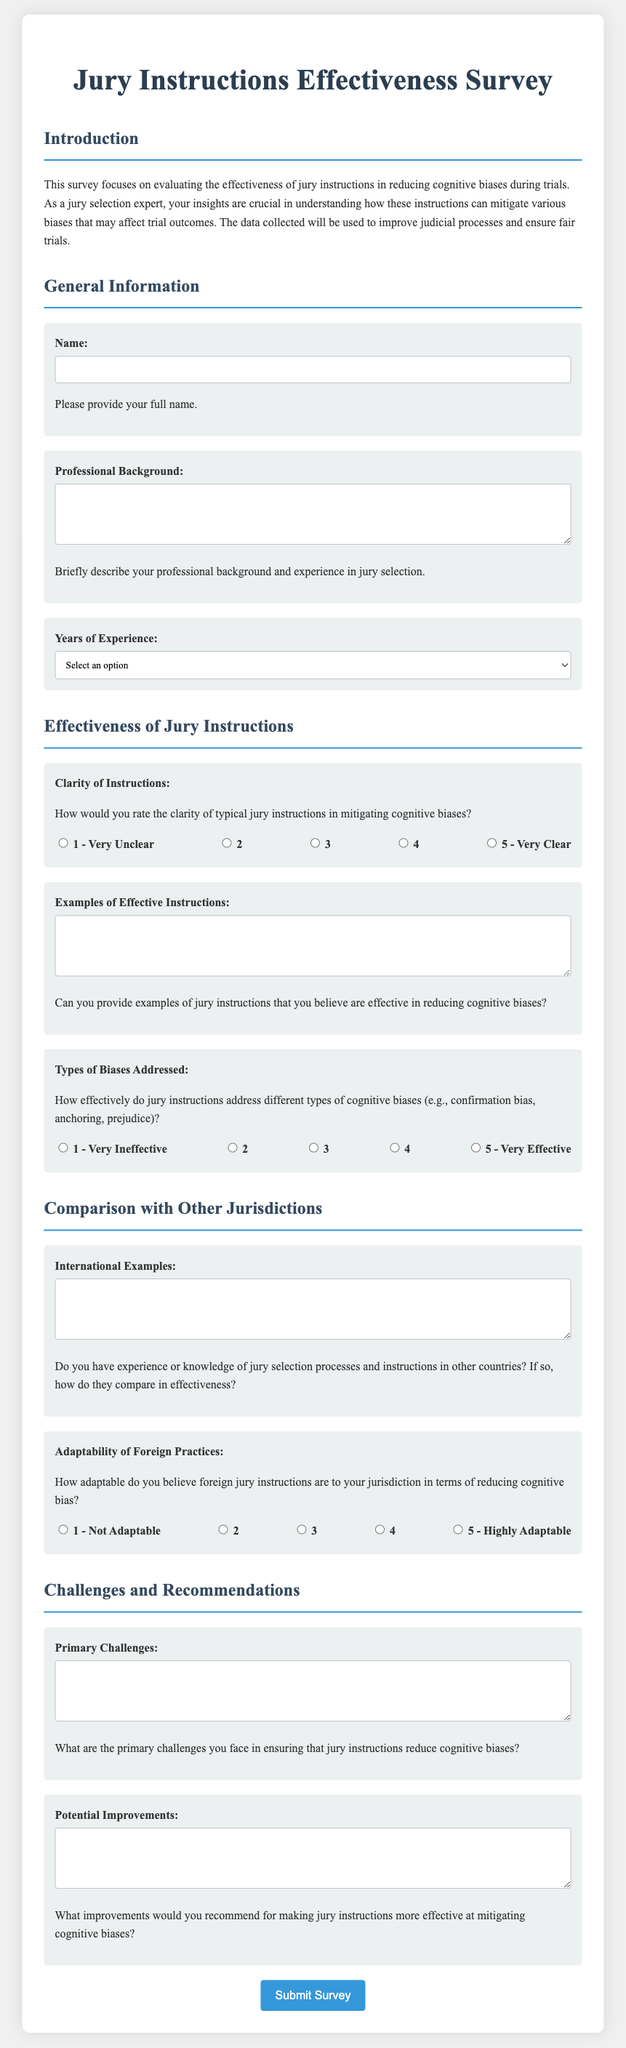What is the title of the survey? The title of the survey is stated at the top of the document.
Answer: Jury Instructions Effectiveness Survey How many sections are there in the survey? The survey has multiple distinct sections for organization, each addressing different themes.
Answer: 5 What is the required response for the "Name" question? The instructions indicate that the "Name" question must be filled out.
Answer: Full name What rating scale options are provided for the clarity of instructions? The document lists a range of one to five to rate clarity.
Answer: 1 to 5 What type of information is requested in the "Examples of Effective Instructions" question? The question specifically asks for examples relating to specific instructions that mitigate bias.
Answer: Jury instructions How is the question about "Adaptability of Foreign Practices" formatted? The document presents this question with a rating scale to assess adaptability.
Answer: Rating scale What does the survey aim to evaluate? The purpose of the survey is clearly defined in the introduction.
Answer: Effectiveness of jury instructions What format is used for the "Years of Experience" question? The question provides predefined options for the respondent to select.
Answer: Dropdown selection What is one topic addressed in the "Challenges and Recommendations" section? This section asks respondents to discuss issues faced regarding jury instructions.
Answer: Primary challenges 